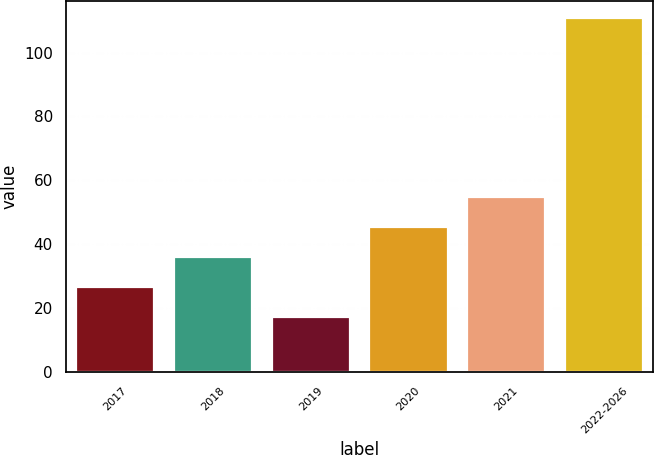Convert chart to OTSL. <chart><loc_0><loc_0><loc_500><loc_500><bar_chart><fcel>2017<fcel>2018<fcel>2019<fcel>2020<fcel>2021<fcel>2022-2026<nl><fcel>26.64<fcel>35.98<fcel>17.3<fcel>45.32<fcel>54.66<fcel>110.7<nl></chart> 